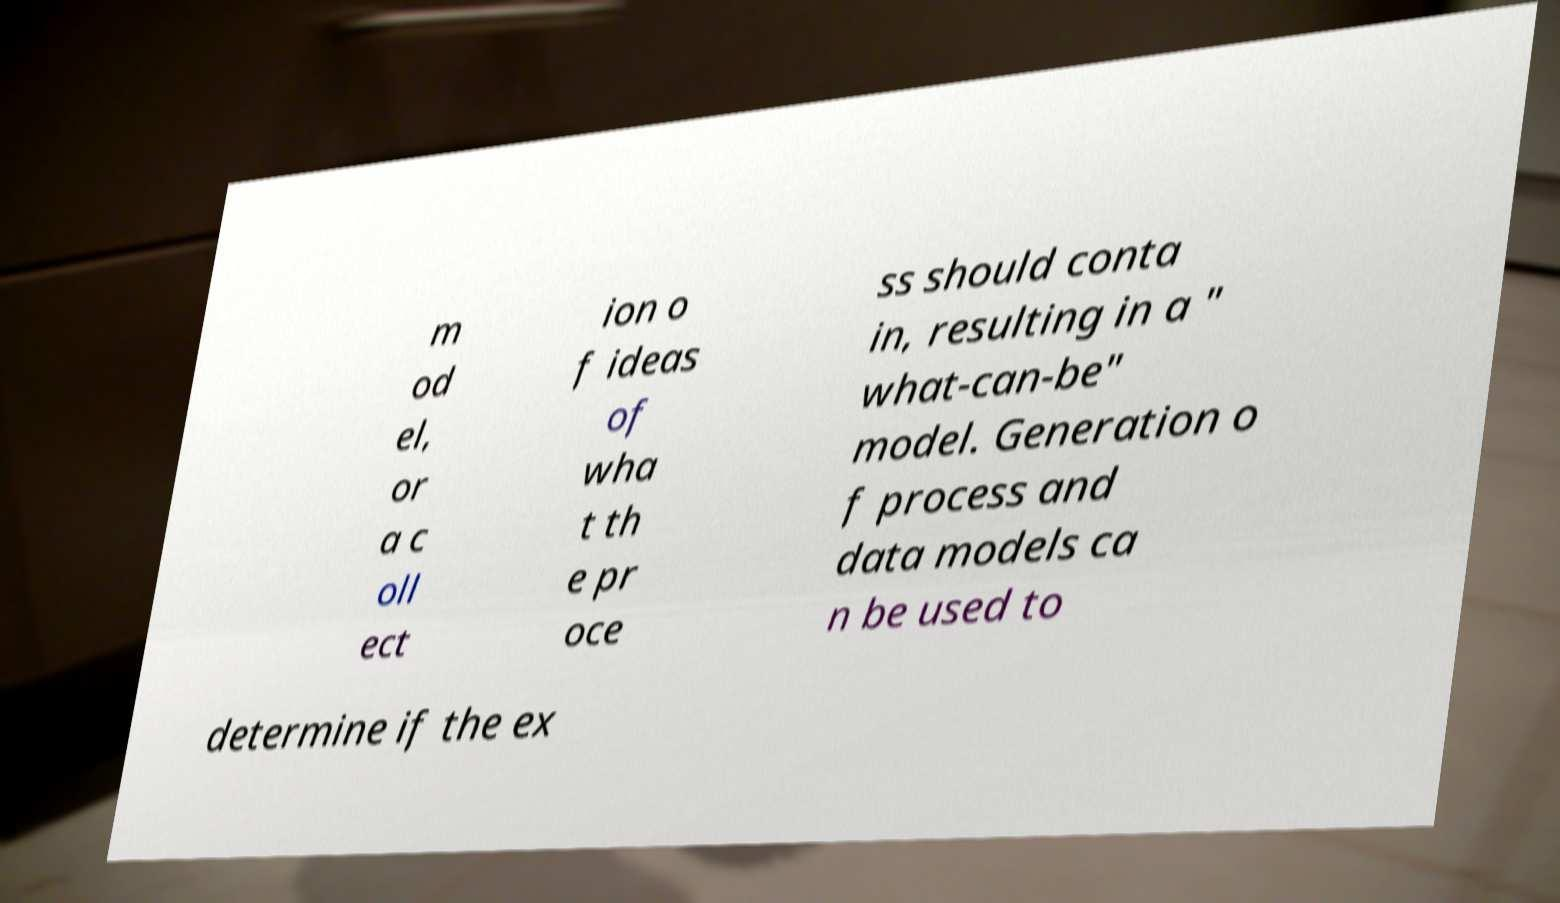I need the written content from this picture converted into text. Can you do that? m od el, or a c oll ect ion o f ideas of wha t th e pr oce ss should conta in, resulting in a " what-can-be" model. Generation o f process and data models ca n be used to determine if the ex 